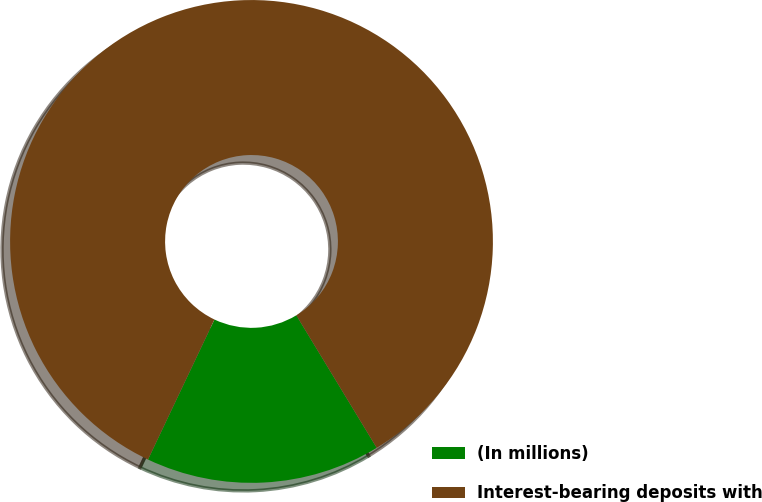<chart> <loc_0><loc_0><loc_500><loc_500><pie_chart><fcel>(In millions)<fcel>Interest-bearing deposits with<nl><fcel>15.73%<fcel>84.27%<nl></chart> 